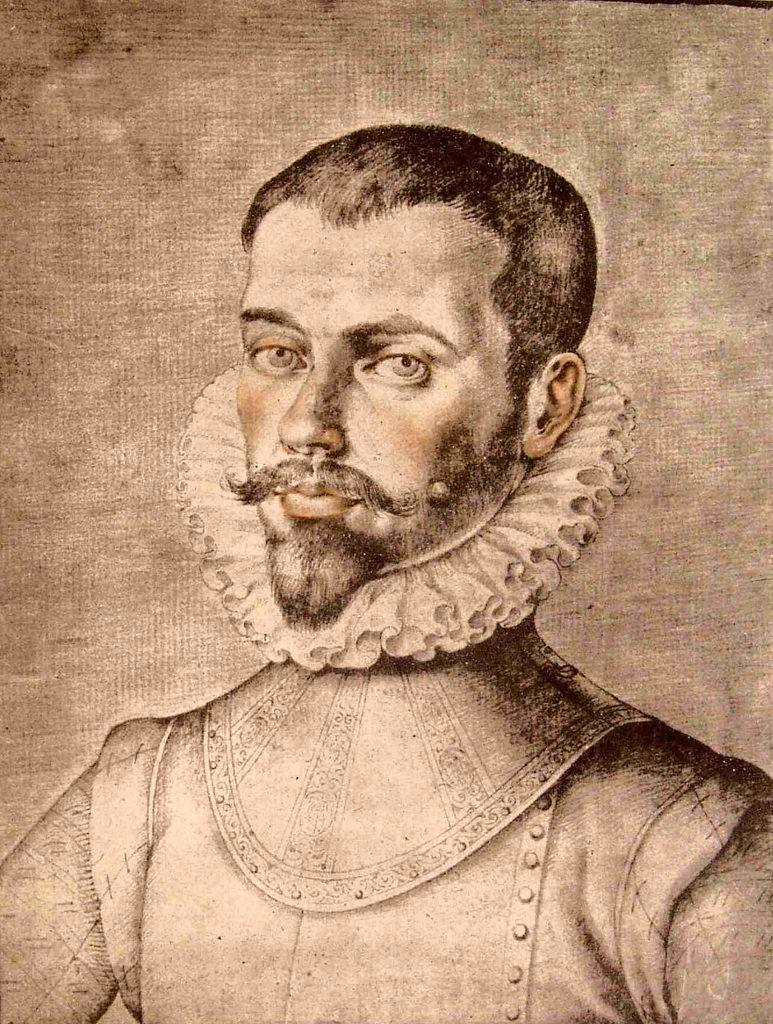What is depicted in the image? There is a sketch of a man in the image. What is the background color of the sketch? The sketch is on a cream-colored surface. What color is the sketch itself? The sketch is in black color. What type of wine is being poured on the marble surface in the image? There is no wine or marble surface present in the image; it features a sketch of a man on a cream-colored surface. Is there a volleyball game happening in the background of the image? There is no volleyball game or any reference to sports in the image; it features a sketch of a man on a cream-colored surface. 